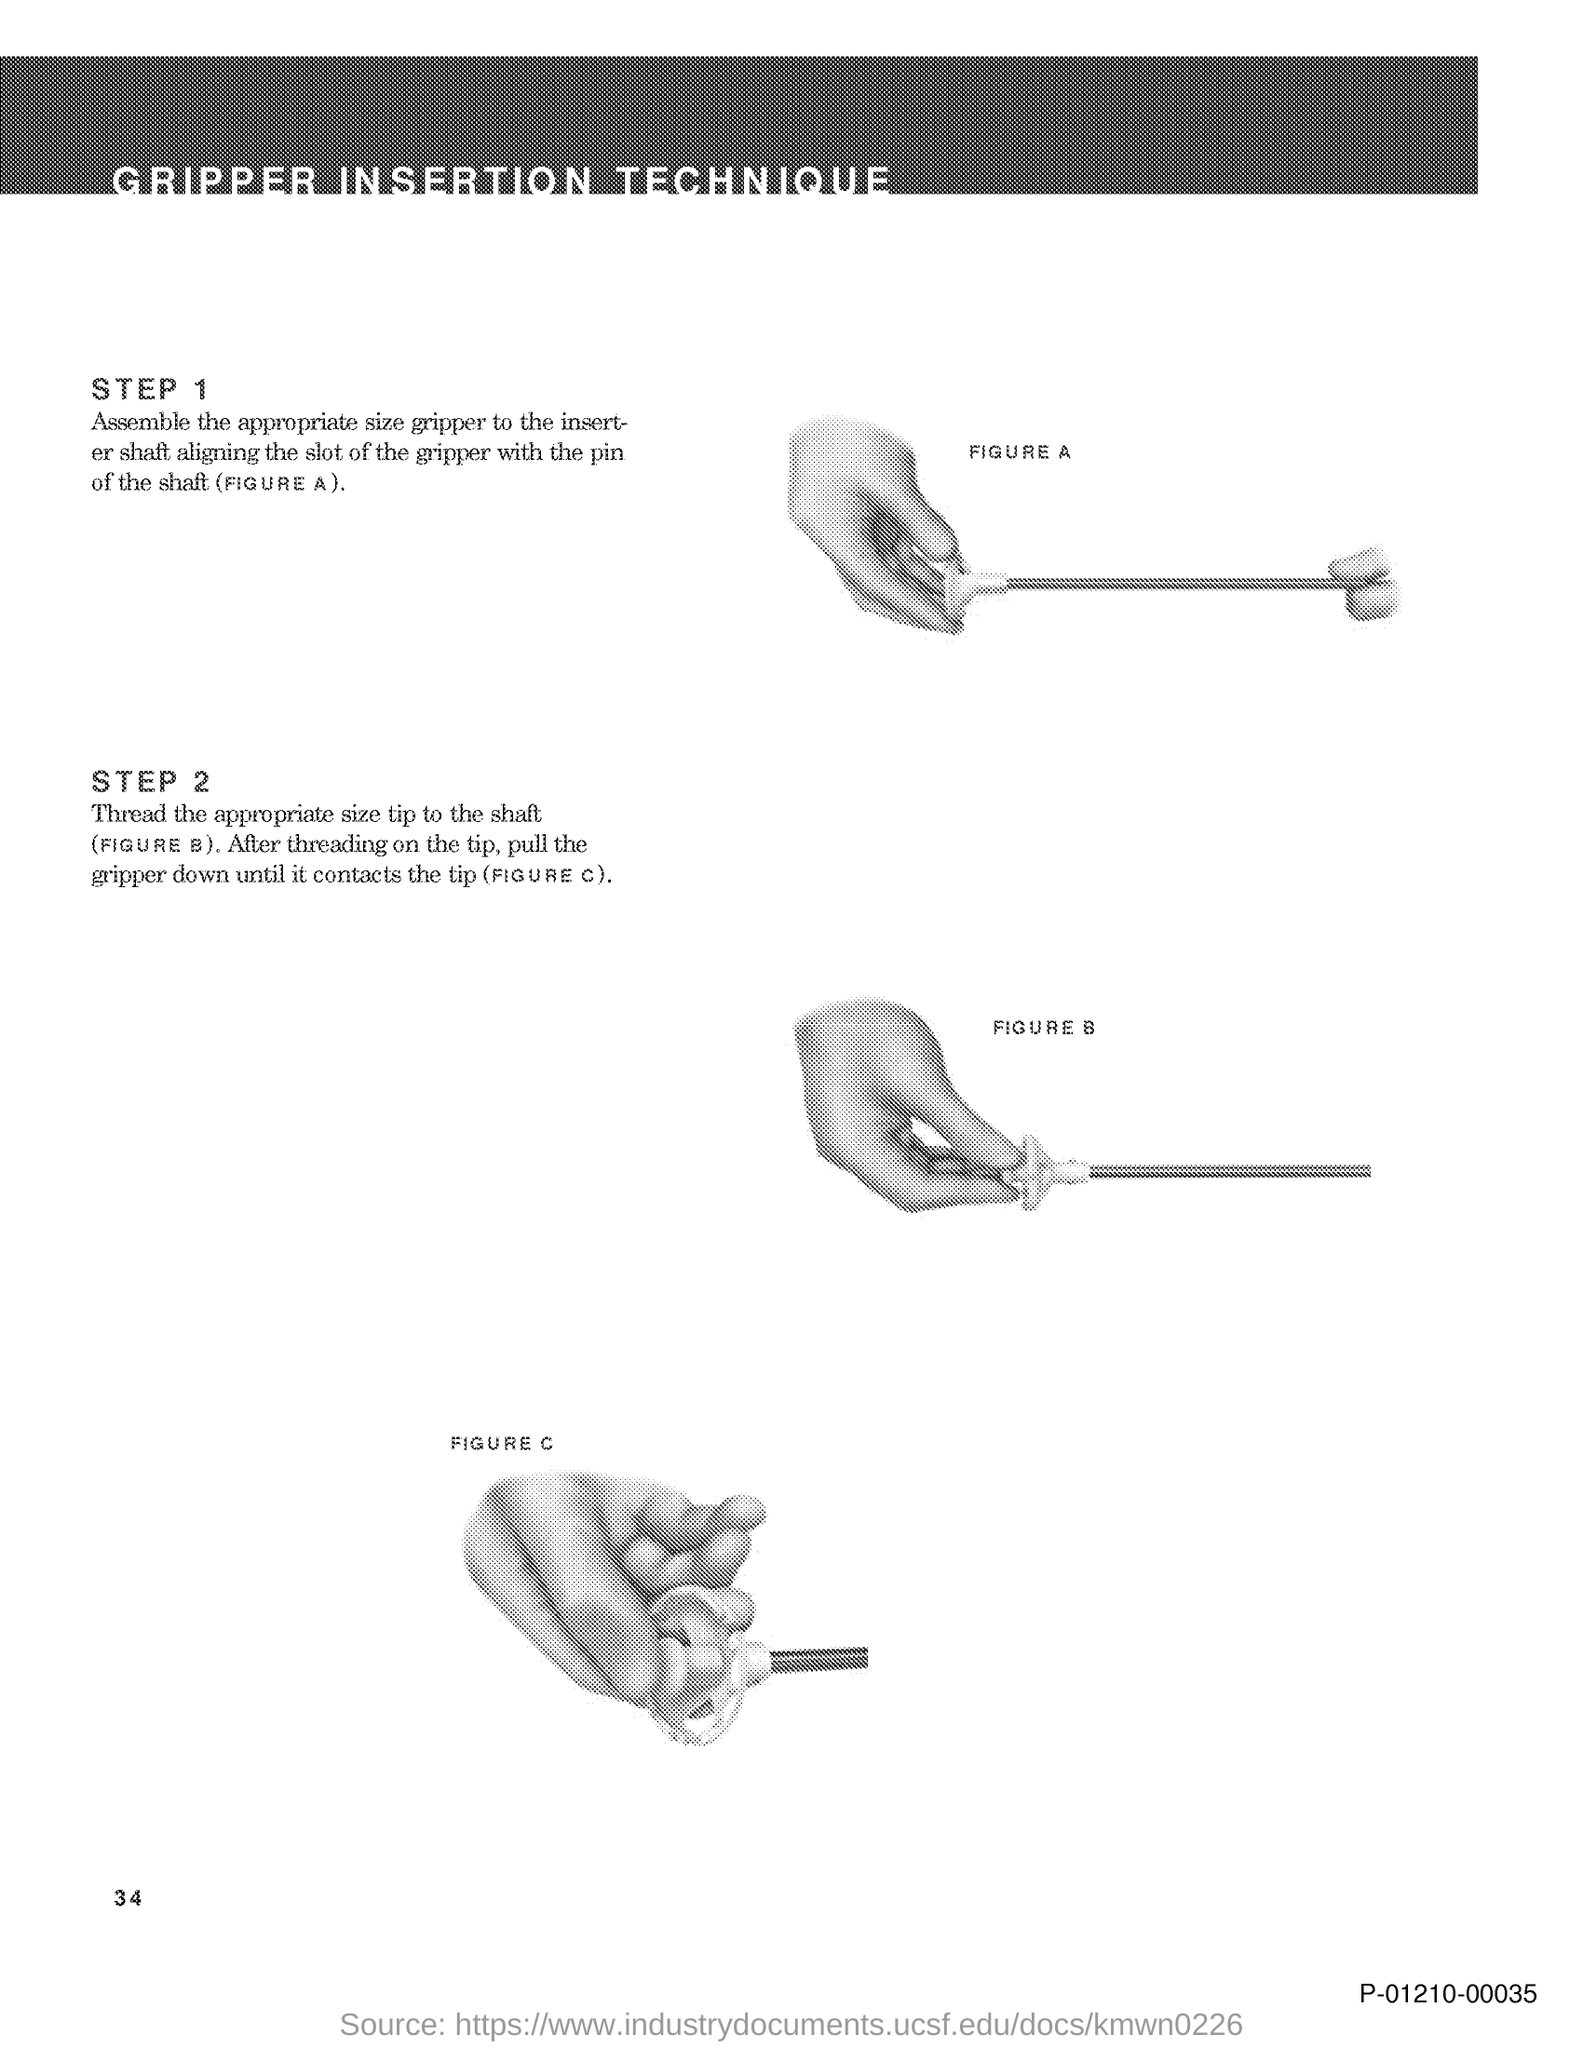What is the title of the document?
Keep it short and to the point. Gripper Insertion Technique. What is the Page Number?
Give a very brief answer. 34. 